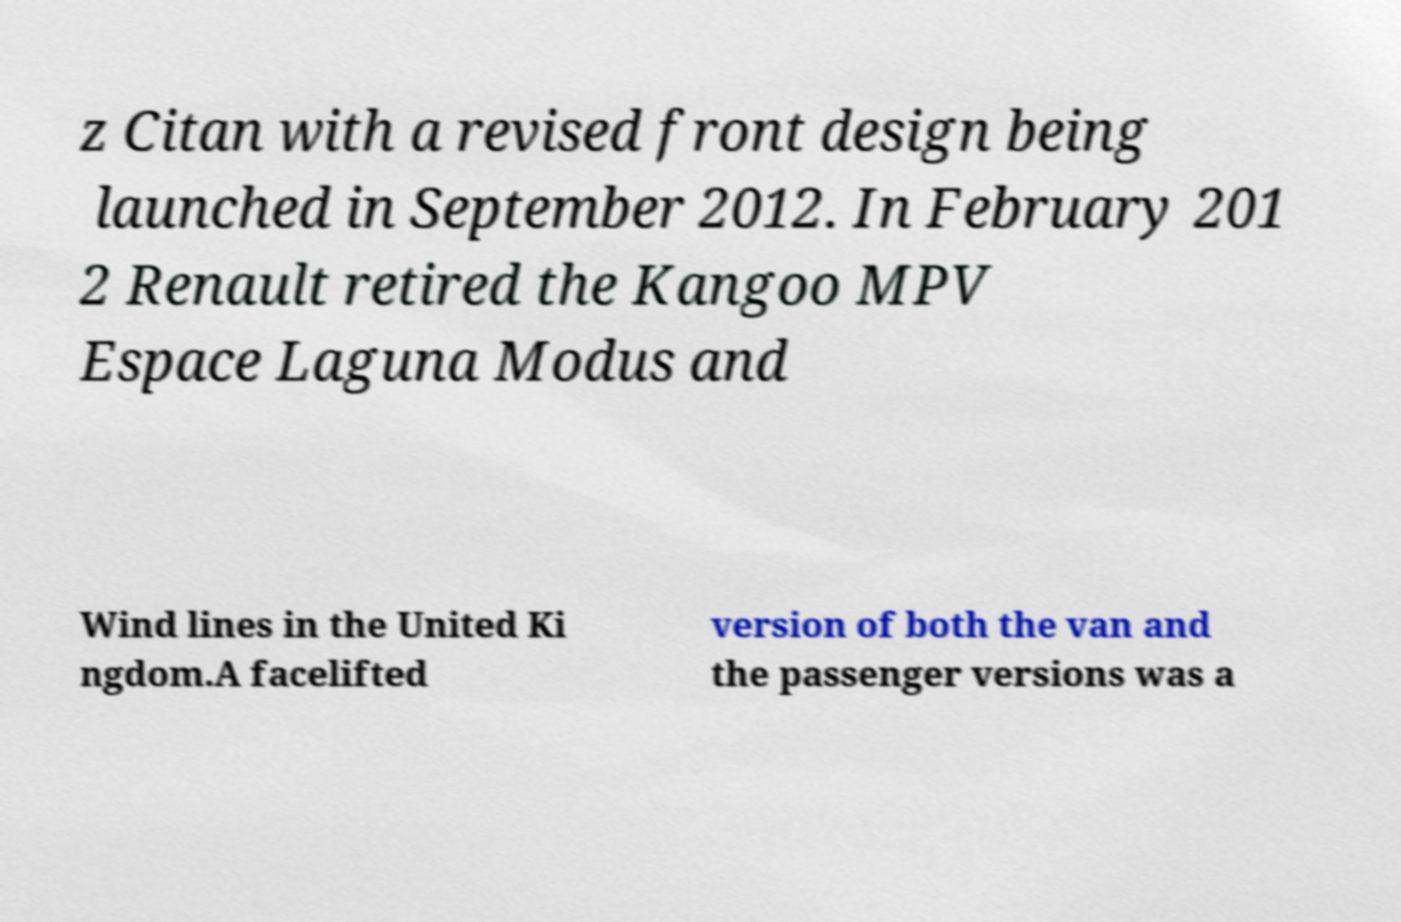Can you read and provide the text displayed in the image?This photo seems to have some interesting text. Can you extract and type it out for me? z Citan with a revised front design being launched in September 2012. In February 201 2 Renault retired the Kangoo MPV Espace Laguna Modus and Wind lines in the United Ki ngdom.A facelifted version of both the van and the passenger versions was a 